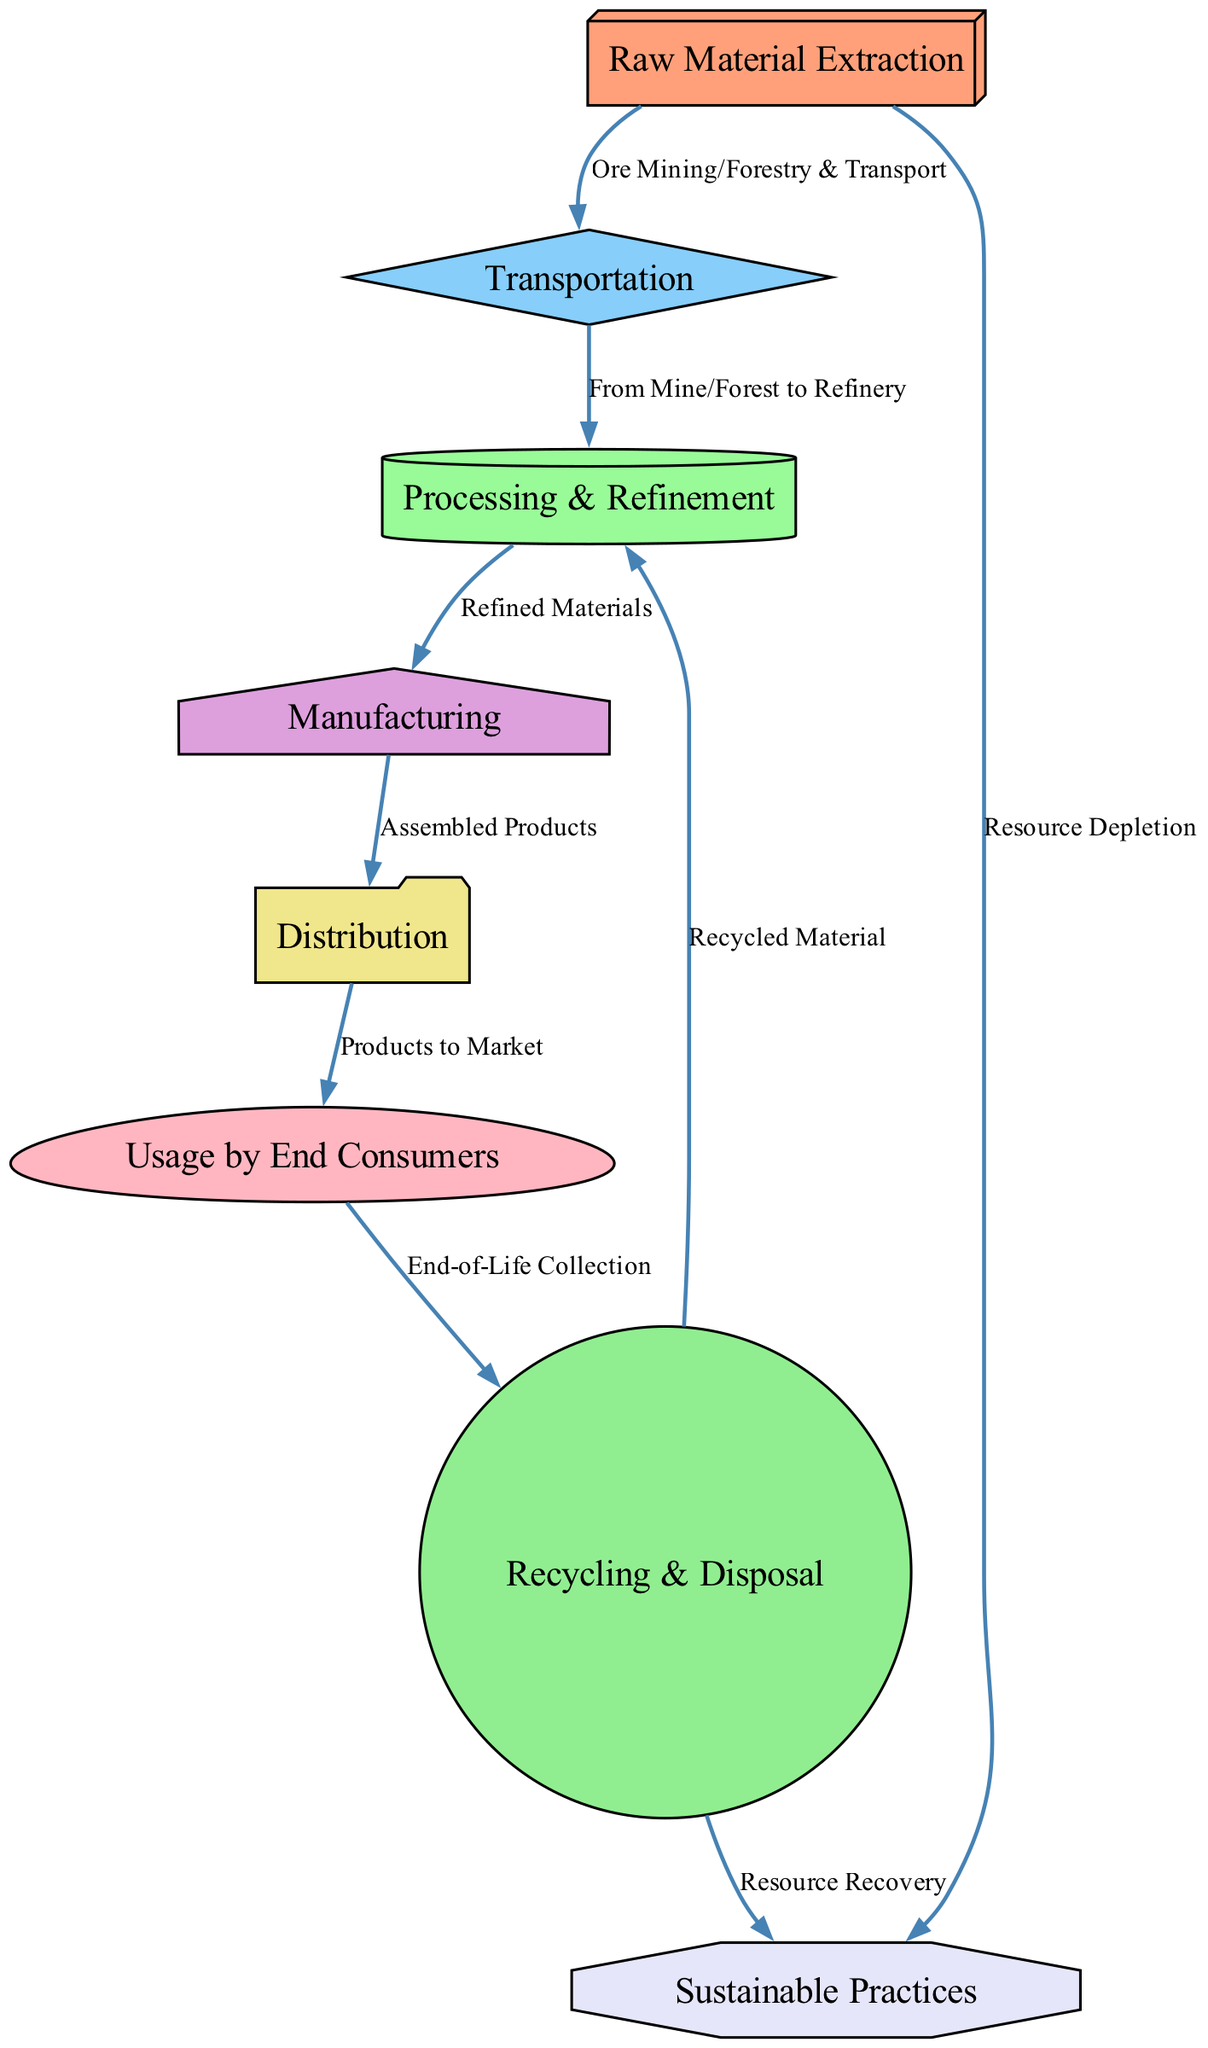What is the first step in the lifecycle of raw materials? The diagram starts with the "Raw Material Extraction" node, indicating that extraction is the initial stage before any other processes.
Answer: Raw Material Extraction How many nodes are present in the diagram? By counting the nodes listed, there are a total of eight distinct nodes that represent various stages in the lifecycle of raw materials.
Answer: Eight What follows after "Raw Material Extraction"? The diagram shows a directional arrow leading from "Raw Material Extraction" to "Transportation," indicating that transportation is the next step in the lifecycle.
Answer: Transportation Which node is associated with "End-of-Life Collection"? The node labeled "Recycling & Disposal" is connected to the "Usage by End Consumers" node, which indicates the collection of materials once they reach the end of their useful life.
Answer: Recycling & Disposal What are the two paths leading to "Sustainable Practices"? The first path connects "Raw Material Extraction" to "Sustainable Practices," focusing on resource depletion, while the second path links "Recycling & Disposal" to "Sustainable Practices," emphasizing resource recovery.
Answer: Resource Depletion and Resource Recovery What is the label of the edge connecting "Processing & Refinement" to "Manufacturing"? The edge connecting these two nodes indicates that the refined materials from "Processing & Refinement" transition into the "Manufacturing" stage, and the label on that edge states "Refined Materials."
Answer: Refined Materials What are the two end nodes in the lifecycle? The lifecycle ends with "Usage by End Consumers" and "Recycling & Disposal," which represent the final stages of product utilization and material recovery, respectively.
Answer: Usage by End Consumers and Recycling & Disposal Which node can be considered a recycling opportunity following "Usage by End Consumers"? Following the "Usage by End Consumers" node, the diagram shows a connection leading to "Recycling & Disposal," identifying this as the opportunity for recycling after product use.
Answer: Recycling & Disposal What is the last stage in the lifecycle that feeds back into "Processing & Refinement"? The recycling stage, represented as "Recycling & Disposal," feeds recycled materials back into "Processing & Refinement," illustrating the closed-loop nature of the lifecycle.
Answer: Recycling & Disposal 